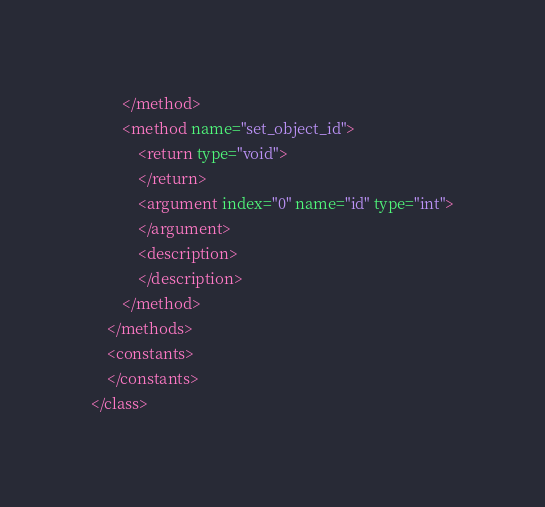Convert code to text. <code><loc_0><loc_0><loc_500><loc_500><_XML_>		</method>
		<method name="set_object_id">
			<return type="void">
			</return>
			<argument index="0" name="id" type="int">
			</argument>
			<description>
			</description>
		</method>
	</methods>
	<constants>
	</constants>
</class>
</code> 